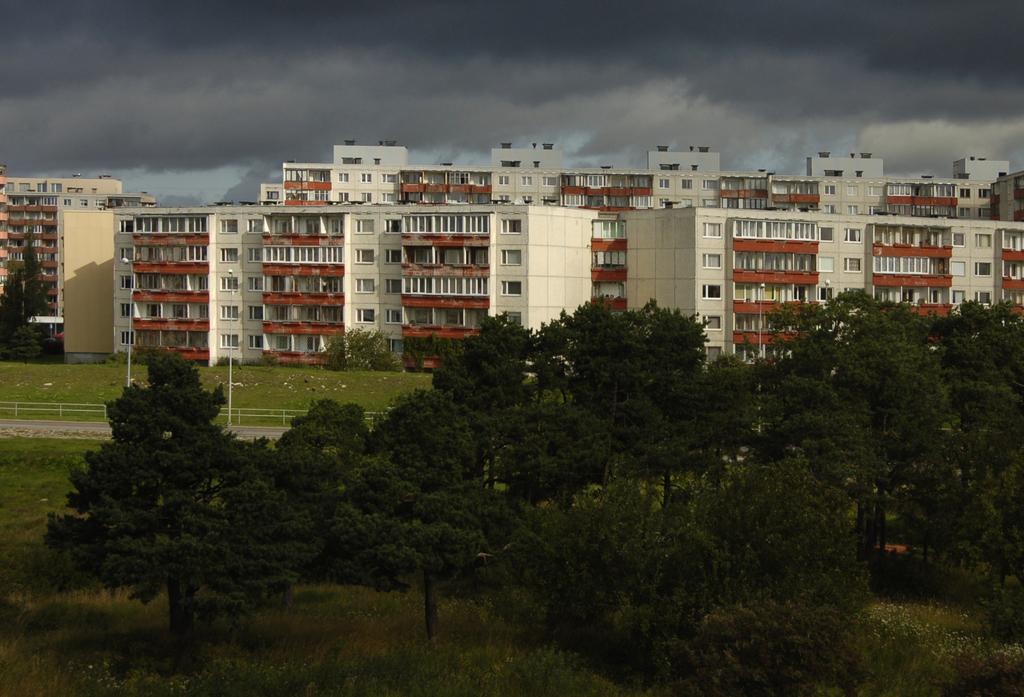Please provide a concise description of this image. In the image we can see there are lot of trees on the ground and the ground is covered with grass. Behind there are lot of buildings and there is a cloudy sky. 